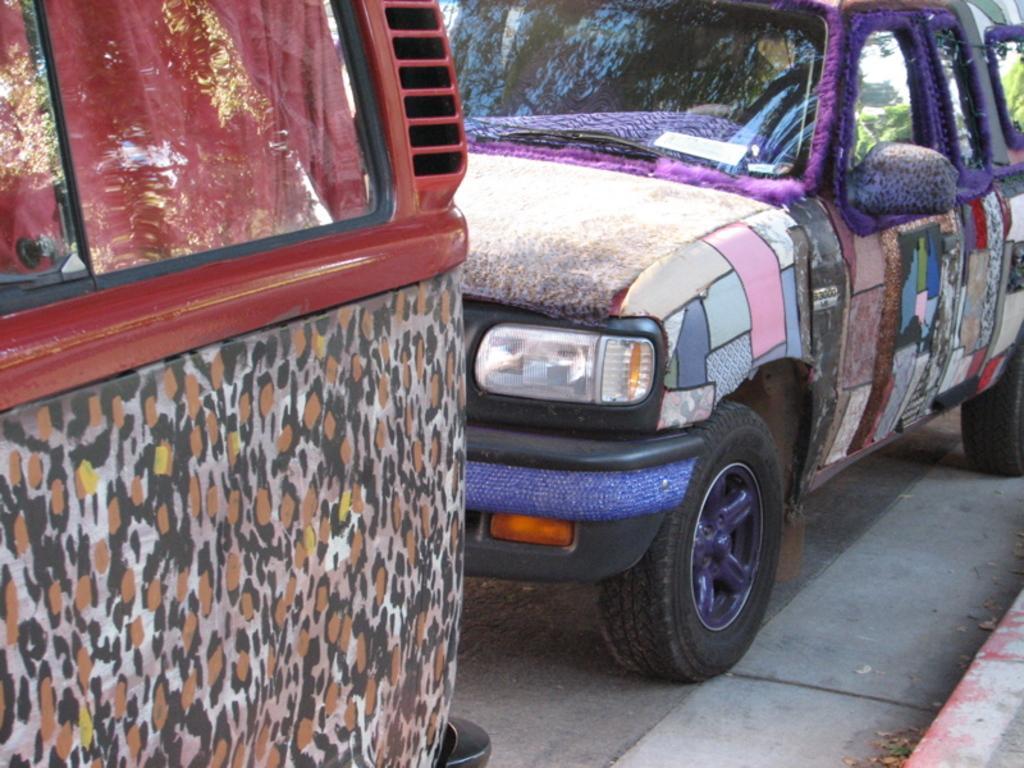Please provide a concise description of this image. In this picture I can see vehicles on the road. 